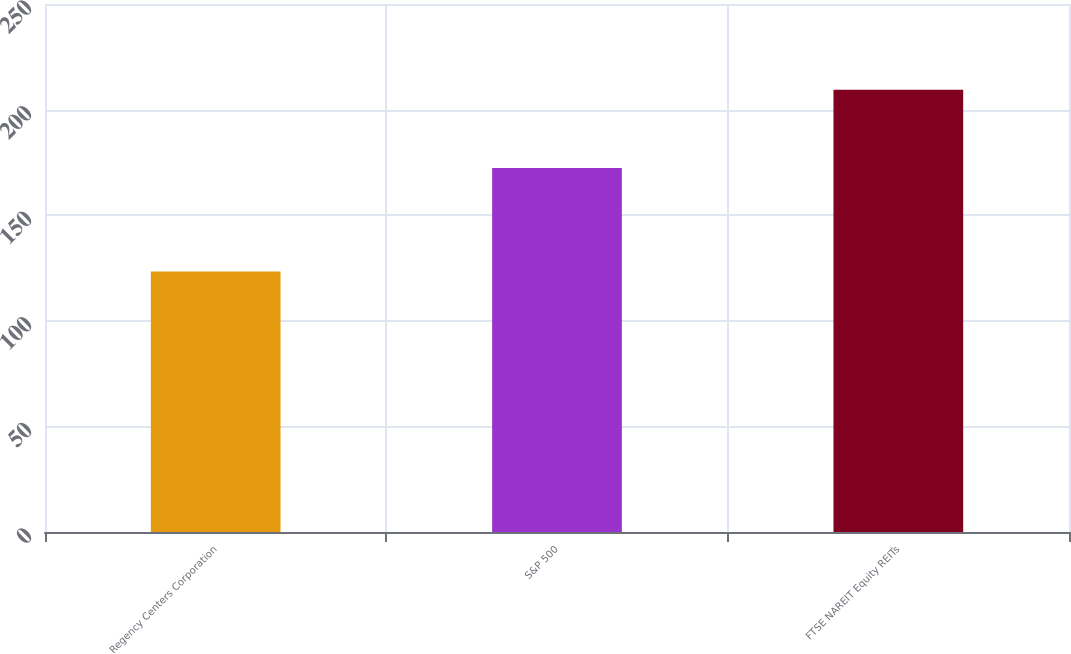Convert chart to OTSL. <chart><loc_0><loc_0><loc_500><loc_500><bar_chart><fcel>Regency Centers Corporation<fcel>S&P 500<fcel>FTSE NAREIT Equity REITs<nl><fcel>123.39<fcel>172.37<fcel>209.39<nl></chart> 